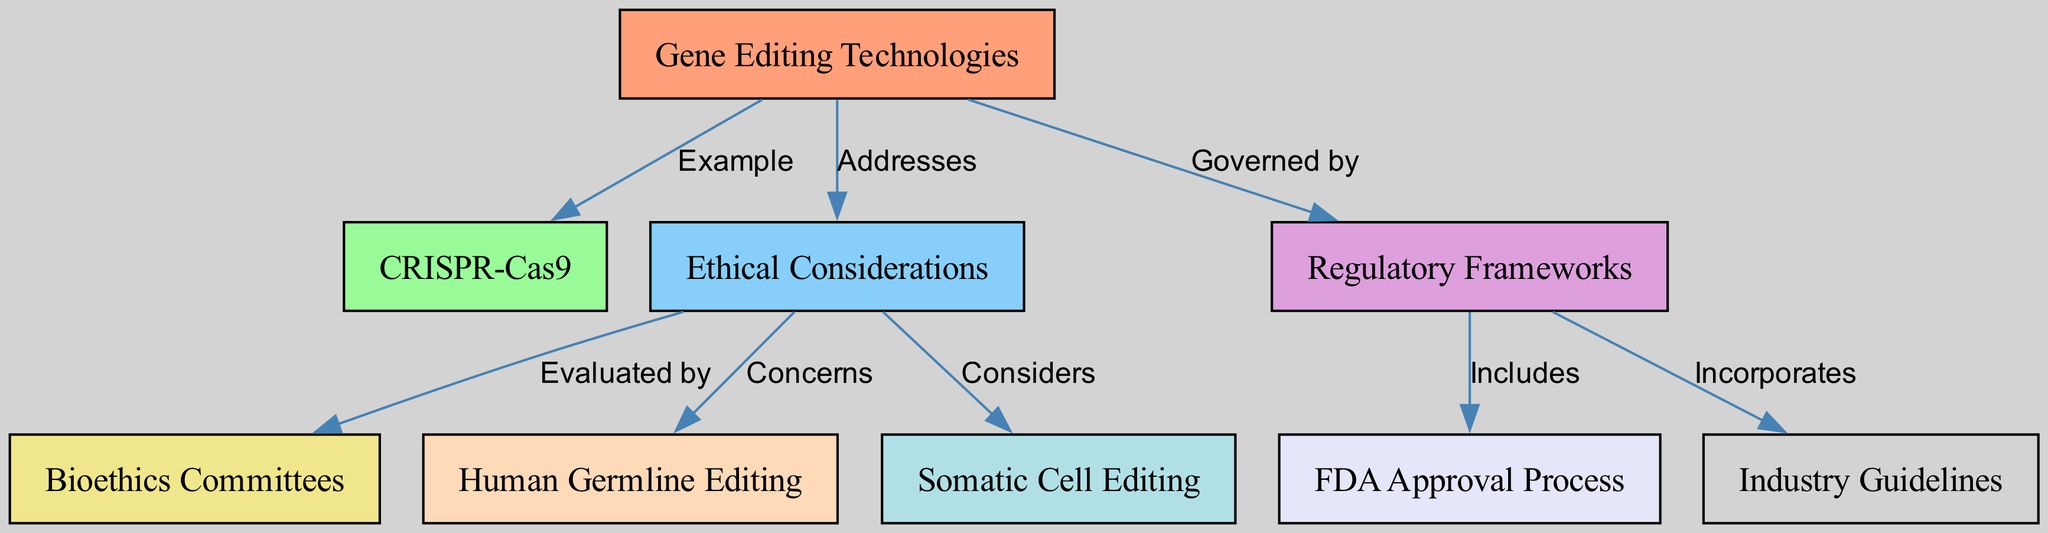What is the main example of gene editing technologies in the diagram? The diagram identifies CRISPR-Cas9 as the main example related to gene editing technologies, indicated by the edge connecting node 1 (Gene Editing Technologies) to node 2 (CRISPR-Cas9) labeled "Example."
Answer: CRISPR-Cas9 How many nodes are in the diagram? By counting the nodes listed in the diagram, there are a total of 9 nodes represented, including various aspects such as ethical considerations, regulatory frameworks, and specific gene editing technologies.
Answer: 9 Which node evaluates ethical considerations in gene editing? The diagram shows that ethical considerations are evaluated by bioethics committees, with an edge from node 3 (Ethical Considerations) to node 5 (Bioethics Committees) labeled "Evaluated by."
Answer: Bioethics Committees What are the two main concerns of ethical considerations according to the diagram? The diagram outlines that ethical considerations encompass concerns related to human germline editing and somatic cell editing, as indicated by the edges connecting node 3 (Ethical Considerations) to nodes 7 (Human Germline Editing) and 8 (Somatic Cell Editing) respectively.
Answer: Human Germline Editing and Somatic Cell Editing What type of editing includes the FDA approval process? The diagram specifies that regulatory frameworks include the FDA approval process, connecting node 4 (Regulatory Frameworks) to node 6 (FDA Approval Process) with the label "Includes."
Answer: Somatic Cell Editing What does the regulatory framework in the diagram incorporate? The diagram indicates that the regulatory frameworks incorporate industry guidelines, shown by the arrow connecting node 4 (Regulatory Frameworks) to node 9 (Industry Guidelines) with the label "Incorporates."
Answer: Industry Guidelines Which two editing types are considered under ethical considerations? The diagram points to human germline editing and somatic cell editing as the types considered under ethical considerations, as these are connected to node 3 (Ethical Considerations) through the respective labeled edges.
Answer: Human Germline Editing and Somatic Cell Editing 